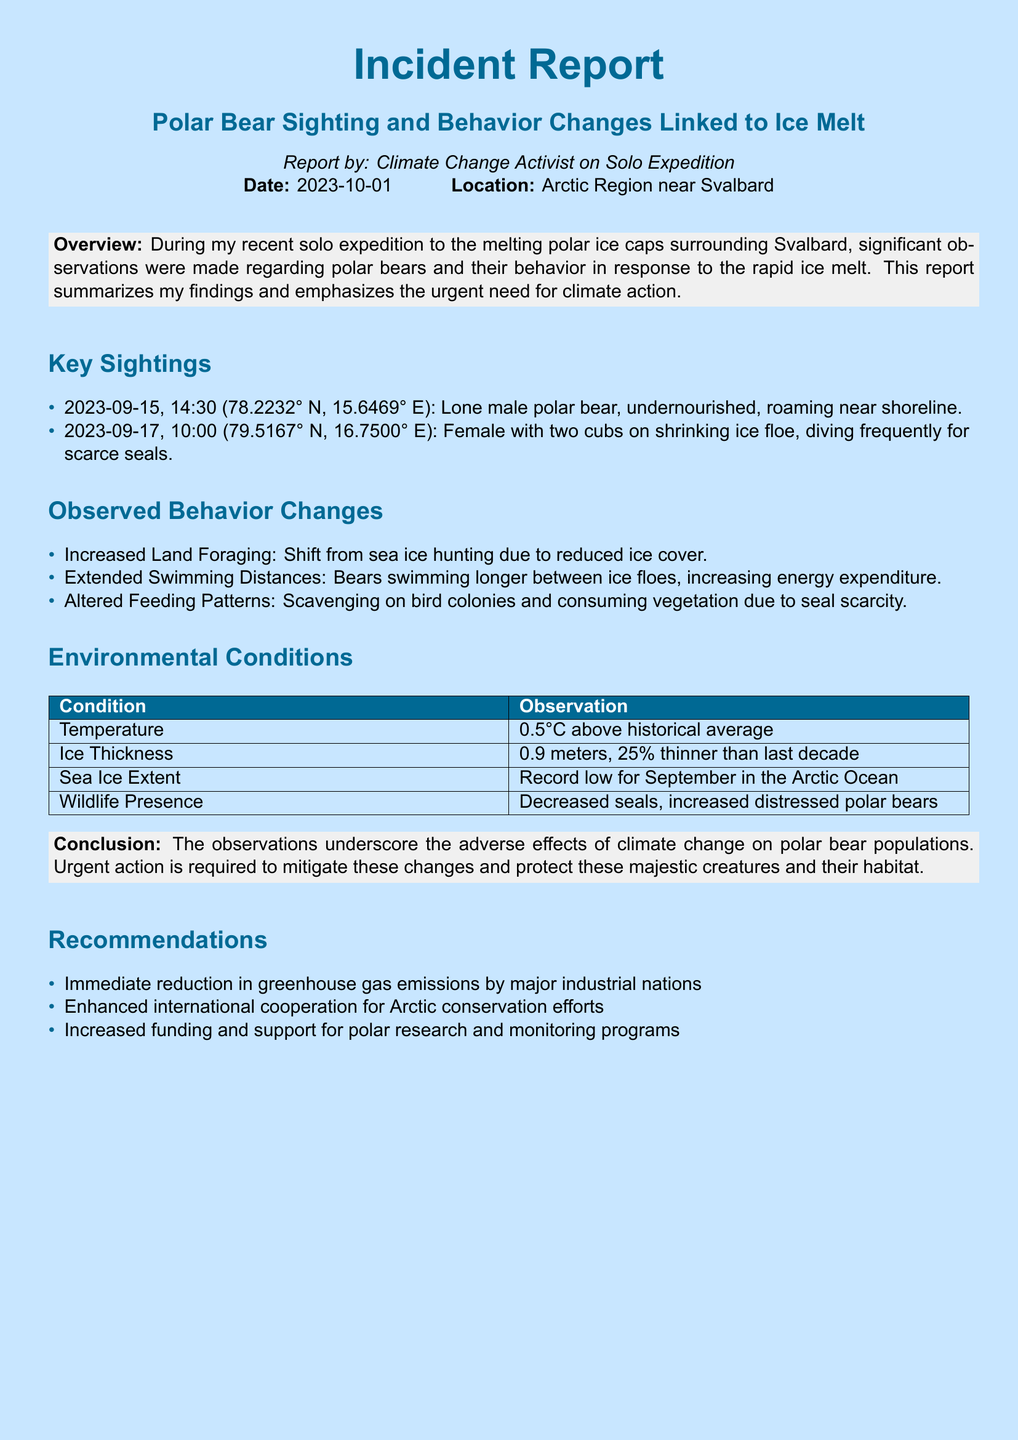What date was the report published? The report indicates the date of publication as 2023-10-01.
Answer: 2023-10-01 What location does the report focus on? The document specifies the location as the Arctic Region near Svalbard.
Answer: Arctic Region near Svalbard How many polar bear cubs were sighted? The report mentions a female polar bear with two cubs.
Answer: two What was the ice thickness observed in the report? The document states that the ice thickness was 0.9 meters.
Answer: 0.9 meters What behavior change involves foraging on land? The report mentions an increase in land foraging due to reduced ice cover.
Answer: Increased Land Foraging What is the temperature anomaly reported? The report indicates a temperature that is 0.5°C above the historical average.
Answer: 0.5°C How many key sightings are reported? The document lists two key sightings in the report.
Answer: two What urgent action is recommended for industrial nations? The report recommends an immediate reduction in greenhouse gas emissions.
Answer: Immediate reduction in greenhouse gas emissions What is the main conclusion of the report? The conclusion emphasizes the adverse effects of climate change on polar bear populations.
Answer: Adverse effects of climate change on polar bear populations 